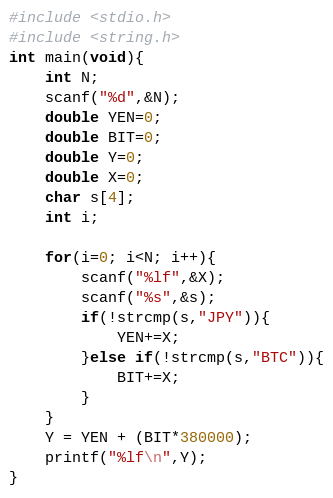Convert code to text. <code><loc_0><loc_0><loc_500><loc_500><_C_>#include <stdio.h>
#include <string.h>
int main(void){
	int N;
	scanf("%d",&N);
	double YEN=0;
	double BIT=0;
	double Y=0;
	double X=0;
	char s[4];
	int i;
	
	for(i=0; i<N; i++){
		scanf("%lf",&X);
		scanf("%s",&s);
		if(!strcmp(s,"JPY")){
			YEN+=X;
		}else if(!strcmp(s,"BTC")){
			BIT+=X;
		}
	}
	Y = YEN + (BIT*380000);
	printf("%lf\n",Y);
}</code> 